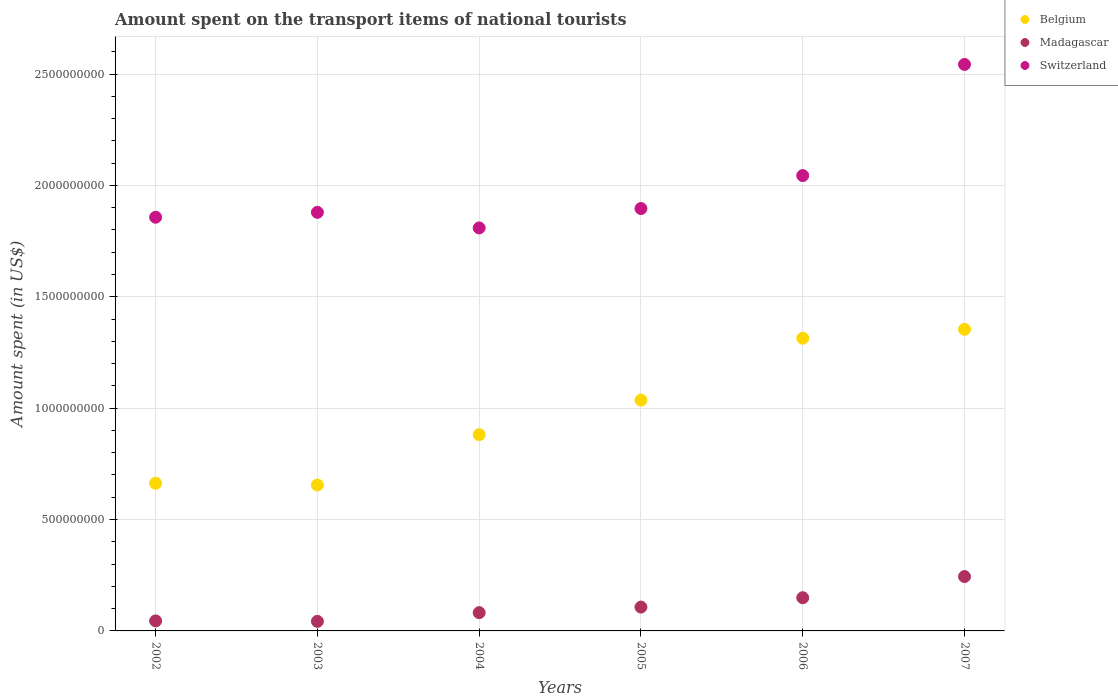How many different coloured dotlines are there?
Ensure brevity in your answer.  3. What is the amount spent on the transport items of national tourists in Madagascar in 2006?
Your answer should be compact. 1.49e+08. Across all years, what is the maximum amount spent on the transport items of national tourists in Switzerland?
Ensure brevity in your answer.  2.54e+09. Across all years, what is the minimum amount spent on the transport items of national tourists in Madagascar?
Your answer should be compact. 4.30e+07. What is the total amount spent on the transport items of national tourists in Madagascar in the graph?
Your response must be concise. 6.70e+08. What is the difference between the amount spent on the transport items of national tourists in Switzerland in 2002 and that in 2004?
Your response must be concise. 4.80e+07. What is the difference between the amount spent on the transport items of national tourists in Belgium in 2006 and the amount spent on the transport items of national tourists in Madagascar in 2002?
Your answer should be compact. 1.27e+09. What is the average amount spent on the transport items of national tourists in Madagascar per year?
Give a very brief answer. 1.12e+08. In the year 2002, what is the difference between the amount spent on the transport items of national tourists in Madagascar and amount spent on the transport items of national tourists in Switzerland?
Your response must be concise. -1.81e+09. In how many years, is the amount spent on the transport items of national tourists in Madagascar greater than 2100000000 US$?
Offer a terse response. 0. What is the ratio of the amount spent on the transport items of national tourists in Belgium in 2002 to that in 2006?
Your answer should be very brief. 0.5. Is the amount spent on the transport items of national tourists in Madagascar in 2006 less than that in 2007?
Your answer should be compact. Yes. Is the difference between the amount spent on the transport items of national tourists in Madagascar in 2002 and 2006 greater than the difference between the amount spent on the transport items of national tourists in Switzerland in 2002 and 2006?
Keep it short and to the point. Yes. What is the difference between the highest and the second highest amount spent on the transport items of national tourists in Madagascar?
Provide a succinct answer. 9.50e+07. What is the difference between the highest and the lowest amount spent on the transport items of national tourists in Switzerland?
Your answer should be very brief. 7.34e+08. Is the sum of the amount spent on the transport items of national tourists in Madagascar in 2004 and 2005 greater than the maximum amount spent on the transport items of national tourists in Belgium across all years?
Keep it short and to the point. No. Is the amount spent on the transport items of national tourists in Switzerland strictly less than the amount spent on the transport items of national tourists in Madagascar over the years?
Provide a short and direct response. No. How many dotlines are there?
Provide a short and direct response. 3. How many years are there in the graph?
Give a very brief answer. 6. Are the values on the major ticks of Y-axis written in scientific E-notation?
Provide a succinct answer. No. Does the graph contain grids?
Your answer should be compact. Yes. Where does the legend appear in the graph?
Keep it short and to the point. Top right. How many legend labels are there?
Your response must be concise. 3. What is the title of the graph?
Provide a succinct answer. Amount spent on the transport items of national tourists. What is the label or title of the Y-axis?
Offer a terse response. Amount spent (in US$). What is the Amount spent (in US$) of Belgium in 2002?
Your response must be concise. 6.63e+08. What is the Amount spent (in US$) in Madagascar in 2002?
Your answer should be very brief. 4.50e+07. What is the Amount spent (in US$) in Switzerland in 2002?
Your response must be concise. 1.86e+09. What is the Amount spent (in US$) of Belgium in 2003?
Provide a succinct answer. 6.55e+08. What is the Amount spent (in US$) of Madagascar in 2003?
Keep it short and to the point. 4.30e+07. What is the Amount spent (in US$) of Switzerland in 2003?
Offer a terse response. 1.88e+09. What is the Amount spent (in US$) of Belgium in 2004?
Ensure brevity in your answer.  8.81e+08. What is the Amount spent (in US$) of Madagascar in 2004?
Provide a succinct answer. 8.20e+07. What is the Amount spent (in US$) in Switzerland in 2004?
Provide a succinct answer. 1.81e+09. What is the Amount spent (in US$) of Belgium in 2005?
Your answer should be compact. 1.04e+09. What is the Amount spent (in US$) in Madagascar in 2005?
Offer a very short reply. 1.07e+08. What is the Amount spent (in US$) in Switzerland in 2005?
Provide a succinct answer. 1.90e+09. What is the Amount spent (in US$) in Belgium in 2006?
Offer a very short reply. 1.31e+09. What is the Amount spent (in US$) of Madagascar in 2006?
Your answer should be very brief. 1.49e+08. What is the Amount spent (in US$) in Switzerland in 2006?
Your response must be concise. 2.04e+09. What is the Amount spent (in US$) of Belgium in 2007?
Offer a terse response. 1.35e+09. What is the Amount spent (in US$) in Madagascar in 2007?
Your answer should be compact. 2.44e+08. What is the Amount spent (in US$) in Switzerland in 2007?
Your answer should be compact. 2.54e+09. Across all years, what is the maximum Amount spent (in US$) in Belgium?
Your answer should be compact. 1.35e+09. Across all years, what is the maximum Amount spent (in US$) in Madagascar?
Provide a short and direct response. 2.44e+08. Across all years, what is the maximum Amount spent (in US$) in Switzerland?
Offer a very short reply. 2.54e+09. Across all years, what is the minimum Amount spent (in US$) in Belgium?
Your answer should be very brief. 6.55e+08. Across all years, what is the minimum Amount spent (in US$) of Madagascar?
Ensure brevity in your answer.  4.30e+07. Across all years, what is the minimum Amount spent (in US$) in Switzerland?
Make the answer very short. 1.81e+09. What is the total Amount spent (in US$) of Belgium in the graph?
Keep it short and to the point. 5.90e+09. What is the total Amount spent (in US$) in Madagascar in the graph?
Your answer should be very brief. 6.70e+08. What is the total Amount spent (in US$) in Switzerland in the graph?
Ensure brevity in your answer.  1.20e+1. What is the difference between the Amount spent (in US$) in Madagascar in 2002 and that in 2003?
Provide a succinct answer. 2.00e+06. What is the difference between the Amount spent (in US$) of Switzerland in 2002 and that in 2003?
Your response must be concise. -2.20e+07. What is the difference between the Amount spent (in US$) in Belgium in 2002 and that in 2004?
Your response must be concise. -2.18e+08. What is the difference between the Amount spent (in US$) in Madagascar in 2002 and that in 2004?
Provide a succinct answer. -3.70e+07. What is the difference between the Amount spent (in US$) of Switzerland in 2002 and that in 2004?
Give a very brief answer. 4.80e+07. What is the difference between the Amount spent (in US$) of Belgium in 2002 and that in 2005?
Offer a very short reply. -3.73e+08. What is the difference between the Amount spent (in US$) of Madagascar in 2002 and that in 2005?
Ensure brevity in your answer.  -6.20e+07. What is the difference between the Amount spent (in US$) in Switzerland in 2002 and that in 2005?
Offer a terse response. -3.90e+07. What is the difference between the Amount spent (in US$) of Belgium in 2002 and that in 2006?
Offer a terse response. -6.51e+08. What is the difference between the Amount spent (in US$) in Madagascar in 2002 and that in 2006?
Offer a very short reply. -1.04e+08. What is the difference between the Amount spent (in US$) of Switzerland in 2002 and that in 2006?
Your answer should be very brief. -1.87e+08. What is the difference between the Amount spent (in US$) of Belgium in 2002 and that in 2007?
Offer a terse response. -6.91e+08. What is the difference between the Amount spent (in US$) in Madagascar in 2002 and that in 2007?
Make the answer very short. -1.99e+08. What is the difference between the Amount spent (in US$) in Switzerland in 2002 and that in 2007?
Your response must be concise. -6.86e+08. What is the difference between the Amount spent (in US$) in Belgium in 2003 and that in 2004?
Give a very brief answer. -2.26e+08. What is the difference between the Amount spent (in US$) of Madagascar in 2003 and that in 2004?
Your answer should be very brief. -3.90e+07. What is the difference between the Amount spent (in US$) of Switzerland in 2003 and that in 2004?
Ensure brevity in your answer.  7.00e+07. What is the difference between the Amount spent (in US$) of Belgium in 2003 and that in 2005?
Offer a very short reply. -3.81e+08. What is the difference between the Amount spent (in US$) of Madagascar in 2003 and that in 2005?
Your response must be concise. -6.40e+07. What is the difference between the Amount spent (in US$) of Switzerland in 2003 and that in 2005?
Give a very brief answer. -1.70e+07. What is the difference between the Amount spent (in US$) in Belgium in 2003 and that in 2006?
Ensure brevity in your answer.  -6.59e+08. What is the difference between the Amount spent (in US$) of Madagascar in 2003 and that in 2006?
Ensure brevity in your answer.  -1.06e+08. What is the difference between the Amount spent (in US$) of Switzerland in 2003 and that in 2006?
Provide a succinct answer. -1.65e+08. What is the difference between the Amount spent (in US$) of Belgium in 2003 and that in 2007?
Keep it short and to the point. -6.99e+08. What is the difference between the Amount spent (in US$) of Madagascar in 2003 and that in 2007?
Provide a short and direct response. -2.01e+08. What is the difference between the Amount spent (in US$) of Switzerland in 2003 and that in 2007?
Ensure brevity in your answer.  -6.64e+08. What is the difference between the Amount spent (in US$) of Belgium in 2004 and that in 2005?
Provide a succinct answer. -1.55e+08. What is the difference between the Amount spent (in US$) of Madagascar in 2004 and that in 2005?
Make the answer very short. -2.50e+07. What is the difference between the Amount spent (in US$) of Switzerland in 2004 and that in 2005?
Your response must be concise. -8.70e+07. What is the difference between the Amount spent (in US$) in Belgium in 2004 and that in 2006?
Provide a short and direct response. -4.33e+08. What is the difference between the Amount spent (in US$) in Madagascar in 2004 and that in 2006?
Make the answer very short. -6.70e+07. What is the difference between the Amount spent (in US$) of Switzerland in 2004 and that in 2006?
Make the answer very short. -2.35e+08. What is the difference between the Amount spent (in US$) in Belgium in 2004 and that in 2007?
Your response must be concise. -4.73e+08. What is the difference between the Amount spent (in US$) in Madagascar in 2004 and that in 2007?
Your answer should be compact. -1.62e+08. What is the difference between the Amount spent (in US$) in Switzerland in 2004 and that in 2007?
Offer a terse response. -7.34e+08. What is the difference between the Amount spent (in US$) of Belgium in 2005 and that in 2006?
Ensure brevity in your answer.  -2.78e+08. What is the difference between the Amount spent (in US$) in Madagascar in 2005 and that in 2006?
Your response must be concise. -4.20e+07. What is the difference between the Amount spent (in US$) of Switzerland in 2005 and that in 2006?
Ensure brevity in your answer.  -1.48e+08. What is the difference between the Amount spent (in US$) of Belgium in 2005 and that in 2007?
Offer a terse response. -3.18e+08. What is the difference between the Amount spent (in US$) in Madagascar in 2005 and that in 2007?
Offer a terse response. -1.37e+08. What is the difference between the Amount spent (in US$) of Switzerland in 2005 and that in 2007?
Keep it short and to the point. -6.47e+08. What is the difference between the Amount spent (in US$) of Belgium in 2006 and that in 2007?
Provide a short and direct response. -4.00e+07. What is the difference between the Amount spent (in US$) of Madagascar in 2006 and that in 2007?
Give a very brief answer. -9.50e+07. What is the difference between the Amount spent (in US$) in Switzerland in 2006 and that in 2007?
Your answer should be compact. -4.99e+08. What is the difference between the Amount spent (in US$) of Belgium in 2002 and the Amount spent (in US$) of Madagascar in 2003?
Provide a succinct answer. 6.20e+08. What is the difference between the Amount spent (in US$) of Belgium in 2002 and the Amount spent (in US$) of Switzerland in 2003?
Your answer should be very brief. -1.22e+09. What is the difference between the Amount spent (in US$) of Madagascar in 2002 and the Amount spent (in US$) of Switzerland in 2003?
Give a very brief answer. -1.83e+09. What is the difference between the Amount spent (in US$) of Belgium in 2002 and the Amount spent (in US$) of Madagascar in 2004?
Your answer should be compact. 5.81e+08. What is the difference between the Amount spent (in US$) of Belgium in 2002 and the Amount spent (in US$) of Switzerland in 2004?
Offer a terse response. -1.15e+09. What is the difference between the Amount spent (in US$) in Madagascar in 2002 and the Amount spent (in US$) in Switzerland in 2004?
Offer a terse response. -1.76e+09. What is the difference between the Amount spent (in US$) in Belgium in 2002 and the Amount spent (in US$) in Madagascar in 2005?
Your response must be concise. 5.56e+08. What is the difference between the Amount spent (in US$) of Belgium in 2002 and the Amount spent (in US$) of Switzerland in 2005?
Give a very brief answer. -1.23e+09. What is the difference between the Amount spent (in US$) of Madagascar in 2002 and the Amount spent (in US$) of Switzerland in 2005?
Your response must be concise. -1.85e+09. What is the difference between the Amount spent (in US$) in Belgium in 2002 and the Amount spent (in US$) in Madagascar in 2006?
Your answer should be very brief. 5.14e+08. What is the difference between the Amount spent (in US$) of Belgium in 2002 and the Amount spent (in US$) of Switzerland in 2006?
Your answer should be compact. -1.38e+09. What is the difference between the Amount spent (in US$) in Madagascar in 2002 and the Amount spent (in US$) in Switzerland in 2006?
Give a very brief answer. -2.00e+09. What is the difference between the Amount spent (in US$) of Belgium in 2002 and the Amount spent (in US$) of Madagascar in 2007?
Offer a very short reply. 4.19e+08. What is the difference between the Amount spent (in US$) of Belgium in 2002 and the Amount spent (in US$) of Switzerland in 2007?
Ensure brevity in your answer.  -1.88e+09. What is the difference between the Amount spent (in US$) of Madagascar in 2002 and the Amount spent (in US$) of Switzerland in 2007?
Make the answer very short. -2.50e+09. What is the difference between the Amount spent (in US$) in Belgium in 2003 and the Amount spent (in US$) in Madagascar in 2004?
Offer a very short reply. 5.73e+08. What is the difference between the Amount spent (in US$) in Belgium in 2003 and the Amount spent (in US$) in Switzerland in 2004?
Your answer should be very brief. -1.15e+09. What is the difference between the Amount spent (in US$) in Madagascar in 2003 and the Amount spent (in US$) in Switzerland in 2004?
Provide a short and direct response. -1.77e+09. What is the difference between the Amount spent (in US$) in Belgium in 2003 and the Amount spent (in US$) in Madagascar in 2005?
Give a very brief answer. 5.48e+08. What is the difference between the Amount spent (in US$) in Belgium in 2003 and the Amount spent (in US$) in Switzerland in 2005?
Ensure brevity in your answer.  -1.24e+09. What is the difference between the Amount spent (in US$) of Madagascar in 2003 and the Amount spent (in US$) of Switzerland in 2005?
Your response must be concise. -1.85e+09. What is the difference between the Amount spent (in US$) of Belgium in 2003 and the Amount spent (in US$) of Madagascar in 2006?
Offer a very short reply. 5.06e+08. What is the difference between the Amount spent (in US$) in Belgium in 2003 and the Amount spent (in US$) in Switzerland in 2006?
Your answer should be very brief. -1.39e+09. What is the difference between the Amount spent (in US$) in Madagascar in 2003 and the Amount spent (in US$) in Switzerland in 2006?
Your response must be concise. -2.00e+09. What is the difference between the Amount spent (in US$) of Belgium in 2003 and the Amount spent (in US$) of Madagascar in 2007?
Offer a very short reply. 4.11e+08. What is the difference between the Amount spent (in US$) of Belgium in 2003 and the Amount spent (in US$) of Switzerland in 2007?
Offer a terse response. -1.89e+09. What is the difference between the Amount spent (in US$) of Madagascar in 2003 and the Amount spent (in US$) of Switzerland in 2007?
Offer a terse response. -2.50e+09. What is the difference between the Amount spent (in US$) of Belgium in 2004 and the Amount spent (in US$) of Madagascar in 2005?
Your response must be concise. 7.74e+08. What is the difference between the Amount spent (in US$) of Belgium in 2004 and the Amount spent (in US$) of Switzerland in 2005?
Provide a short and direct response. -1.02e+09. What is the difference between the Amount spent (in US$) in Madagascar in 2004 and the Amount spent (in US$) in Switzerland in 2005?
Ensure brevity in your answer.  -1.81e+09. What is the difference between the Amount spent (in US$) of Belgium in 2004 and the Amount spent (in US$) of Madagascar in 2006?
Provide a short and direct response. 7.32e+08. What is the difference between the Amount spent (in US$) of Belgium in 2004 and the Amount spent (in US$) of Switzerland in 2006?
Give a very brief answer. -1.16e+09. What is the difference between the Amount spent (in US$) in Madagascar in 2004 and the Amount spent (in US$) in Switzerland in 2006?
Give a very brief answer. -1.96e+09. What is the difference between the Amount spent (in US$) of Belgium in 2004 and the Amount spent (in US$) of Madagascar in 2007?
Provide a short and direct response. 6.37e+08. What is the difference between the Amount spent (in US$) in Belgium in 2004 and the Amount spent (in US$) in Switzerland in 2007?
Provide a succinct answer. -1.66e+09. What is the difference between the Amount spent (in US$) of Madagascar in 2004 and the Amount spent (in US$) of Switzerland in 2007?
Keep it short and to the point. -2.46e+09. What is the difference between the Amount spent (in US$) in Belgium in 2005 and the Amount spent (in US$) in Madagascar in 2006?
Provide a short and direct response. 8.87e+08. What is the difference between the Amount spent (in US$) of Belgium in 2005 and the Amount spent (in US$) of Switzerland in 2006?
Provide a short and direct response. -1.01e+09. What is the difference between the Amount spent (in US$) in Madagascar in 2005 and the Amount spent (in US$) in Switzerland in 2006?
Your answer should be compact. -1.94e+09. What is the difference between the Amount spent (in US$) in Belgium in 2005 and the Amount spent (in US$) in Madagascar in 2007?
Offer a very short reply. 7.92e+08. What is the difference between the Amount spent (in US$) in Belgium in 2005 and the Amount spent (in US$) in Switzerland in 2007?
Make the answer very short. -1.51e+09. What is the difference between the Amount spent (in US$) of Madagascar in 2005 and the Amount spent (in US$) of Switzerland in 2007?
Offer a very short reply. -2.44e+09. What is the difference between the Amount spent (in US$) of Belgium in 2006 and the Amount spent (in US$) of Madagascar in 2007?
Provide a succinct answer. 1.07e+09. What is the difference between the Amount spent (in US$) of Belgium in 2006 and the Amount spent (in US$) of Switzerland in 2007?
Make the answer very short. -1.23e+09. What is the difference between the Amount spent (in US$) of Madagascar in 2006 and the Amount spent (in US$) of Switzerland in 2007?
Keep it short and to the point. -2.39e+09. What is the average Amount spent (in US$) in Belgium per year?
Your response must be concise. 9.84e+08. What is the average Amount spent (in US$) in Madagascar per year?
Give a very brief answer. 1.12e+08. What is the average Amount spent (in US$) of Switzerland per year?
Your answer should be very brief. 2.00e+09. In the year 2002, what is the difference between the Amount spent (in US$) of Belgium and Amount spent (in US$) of Madagascar?
Provide a short and direct response. 6.18e+08. In the year 2002, what is the difference between the Amount spent (in US$) in Belgium and Amount spent (in US$) in Switzerland?
Your answer should be compact. -1.19e+09. In the year 2002, what is the difference between the Amount spent (in US$) in Madagascar and Amount spent (in US$) in Switzerland?
Your answer should be compact. -1.81e+09. In the year 2003, what is the difference between the Amount spent (in US$) in Belgium and Amount spent (in US$) in Madagascar?
Your answer should be very brief. 6.12e+08. In the year 2003, what is the difference between the Amount spent (in US$) in Belgium and Amount spent (in US$) in Switzerland?
Keep it short and to the point. -1.22e+09. In the year 2003, what is the difference between the Amount spent (in US$) of Madagascar and Amount spent (in US$) of Switzerland?
Offer a very short reply. -1.84e+09. In the year 2004, what is the difference between the Amount spent (in US$) in Belgium and Amount spent (in US$) in Madagascar?
Your response must be concise. 7.99e+08. In the year 2004, what is the difference between the Amount spent (in US$) in Belgium and Amount spent (in US$) in Switzerland?
Make the answer very short. -9.28e+08. In the year 2004, what is the difference between the Amount spent (in US$) of Madagascar and Amount spent (in US$) of Switzerland?
Make the answer very short. -1.73e+09. In the year 2005, what is the difference between the Amount spent (in US$) of Belgium and Amount spent (in US$) of Madagascar?
Keep it short and to the point. 9.29e+08. In the year 2005, what is the difference between the Amount spent (in US$) of Belgium and Amount spent (in US$) of Switzerland?
Your response must be concise. -8.60e+08. In the year 2005, what is the difference between the Amount spent (in US$) in Madagascar and Amount spent (in US$) in Switzerland?
Keep it short and to the point. -1.79e+09. In the year 2006, what is the difference between the Amount spent (in US$) of Belgium and Amount spent (in US$) of Madagascar?
Provide a short and direct response. 1.16e+09. In the year 2006, what is the difference between the Amount spent (in US$) in Belgium and Amount spent (in US$) in Switzerland?
Offer a terse response. -7.30e+08. In the year 2006, what is the difference between the Amount spent (in US$) in Madagascar and Amount spent (in US$) in Switzerland?
Offer a very short reply. -1.90e+09. In the year 2007, what is the difference between the Amount spent (in US$) of Belgium and Amount spent (in US$) of Madagascar?
Offer a terse response. 1.11e+09. In the year 2007, what is the difference between the Amount spent (in US$) of Belgium and Amount spent (in US$) of Switzerland?
Keep it short and to the point. -1.19e+09. In the year 2007, what is the difference between the Amount spent (in US$) of Madagascar and Amount spent (in US$) of Switzerland?
Your answer should be very brief. -2.30e+09. What is the ratio of the Amount spent (in US$) in Belgium in 2002 to that in 2003?
Your answer should be compact. 1.01. What is the ratio of the Amount spent (in US$) in Madagascar in 2002 to that in 2003?
Ensure brevity in your answer.  1.05. What is the ratio of the Amount spent (in US$) in Switzerland in 2002 to that in 2003?
Give a very brief answer. 0.99. What is the ratio of the Amount spent (in US$) in Belgium in 2002 to that in 2004?
Offer a very short reply. 0.75. What is the ratio of the Amount spent (in US$) in Madagascar in 2002 to that in 2004?
Your response must be concise. 0.55. What is the ratio of the Amount spent (in US$) in Switzerland in 2002 to that in 2004?
Your answer should be compact. 1.03. What is the ratio of the Amount spent (in US$) of Belgium in 2002 to that in 2005?
Offer a very short reply. 0.64. What is the ratio of the Amount spent (in US$) of Madagascar in 2002 to that in 2005?
Your answer should be compact. 0.42. What is the ratio of the Amount spent (in US$) of Switzerland in 2002 to that in 2005?
Give a very brief answer. 0.98. What is the ratio of the Amount spent (in US$) of Belgium in 2002 to that in 2006?
Your answer should be very brief. 0.5. What is the ratio of the Amount spent (in US$) in Madagascar in 2002 to that in 2006?
Make the answer very short. 0.3. What is the ratio of the Amount spent (in US$) of Switzerland in 2002 to that in 2006?
Provide a short and direct response. 0.91. What is the ratio of the Amount spent (in US$) of Belgium in 2002 to that in 2007?
Give a very brief answer. 0.49. What is the ratio of the Amount spent (in US$) in Madagascar in 2002 to that in 2007?
Give a very brief answer. 0.18. What is the ratio of the Amount spent (in US$) in Switzerland in 2002 to that in 2007?
Give a very brief answer. 0.73. What is the ratio of the Amount spent (in US$) of Belgium in 2003 to that in 2004?
Your answer should be compact. 0.74. What is the ratio of the Amount spent (in US$) of Madagascar in 2003 to that in 2004?
Ensure brevity in your answer.  0.52. What is the ratio of the Amount spent (in US$) of Switzerland in 2003 to that in 2004?
Offer a terse response. 1.04. What is the ratio of the Amount spent (in US$) of Belgium in 2003 to that in 2005?
Ensure brevity in your answer.  0.63. What is the ratio of the Amount spent (in US$) in Madagascar in 2003 to that in 2005?
Your answer should be compact. 0.4. What is the ratio of the Amount spent (in US$) of Switzerland in 2003 to that in 2005?
Your answer should be compact. 0.99. What is the ratio of the Amount spent (in US$) in Belgium in 2003 to that in 2006?
Keep it short and to the point. 0.5. What is the ratio of the Amount spent (in US$) in Madagascar in 2003 to that in 2006?
Provide a short and direct response. 0.29. What is the ratio of the Amount spent (in US$) of Switzerland in 2003 to that in 2006?
Provide a short and direct response. 0.92. What is the ratio of the Amount spent (in US$) of Belgium in 2003 to that in 2007?
Provide a succinct answer. 0.48. What is the ratio of the Amount spent (in US$) of Madagascar in 2003 to that in 2007?
Offer a very short reply. 0.18. What is the ratio of the Amount spent (in US$) of Switzerland in 2003 to that in 2007?
Keep it short and to the point. 0.74. What is the ratio of the Amount spent (in US$) in Belgium in 2004 to that in 2005?
Offer a terse response. 0.85. What is the ratio of the Amount spent (in US$) of Madagascar in 2004 to that in 2005?
Your answer should be very brief. 0.77. What is the ratio of the Amount spent (in US$) in Switzerland in 2004 to that in 2005?
Offer a very short reply. 0.95. What is the ratio of the Amount spent (in US$) of Belgium in 2004 to that in 2006?
Your answer should be compact. 0.67. What is the ratio of the Amount spent (in US$) of Madagascar in 2004 to that in 2006?
Keep it short and to the point. 0.55. What is the ratio of the Amount spent (in US$) of Switzerland in 2004 to that in 2006?
Give a very brief answer. 0.89. What is the ratio of the Amount spent (in US$) in Belgium in 2004 to that in 2007?
Make the answer very short. 0.65. What is the ratio of the Amount spent (in US$) in Madagascar in 2004 to that in 2007?
Provide a short and direct response. 0.34. What is the ratio of the Amount spent (in US$) in Switzerland in 2004 to that in 2007?
Your answer should be very brief. 0.71. What is the ratio of the Amount spent (in US$) in Belgium in 2005 to that in 2006?
Provide a short and direct response. 0.79. What is the ratio of the Amount spent (in US$) in Madagascar in 2005 to that in 2006?
Provide a succinct answer. 0.72. What is the ratio of the Amount spent (in US$) of Switzerland in 2005 to that in 2006?
Provide a succinct answer. 0.93. What is the ratio of the Amount spent (in US$) of Belgium in 2005 to that in 2007?
Your response must be concise. 0.77. What is the ratio of the Amount spent (in US$) of Madagascar in 2005 to that in 2007?
Provide a succinct answer. 0.44. What is the ratio of the Amount spent (in US$) in Switzerland in 2005 to that in 2007?
Offer a very short reply. 0.75. What is the ratio of the Amount spent (in US$) in Belgium in 2006 to that in 2007?
Give a very brief answer. 0.97. What is the ratio of the Amount spent (in US$) of Madagascar in 2006 to that in 2007?
Provide a succinct answer. 0.61. What is the ratio of the Amount spent (in US$) in Switzerland in 2006 to that in 2007?
Keep it short and to the point. 0.8. What is the difference between the highest and the second highest Amount spent (in US$) of Belgium?
Provide a short and direct response. 4.00e+07. What is the difference between the highest and the second highest Amount spent (in US$) in Madagascar?
Keep it short and to the point. 9.50e+07. What is the difference between the highest and the second highest Amount spent (in US$) in Switzerland?
Your answer should be very brief. 4.99e+08. What is the difference between the highest and the lowest Amount spent (in US$) in Belgium?
Your answer should be very brief. 6.99e+08. What is the difference between the highest and the lowest Amount spent (in US$) of Madagascar?
Make the answer very short. 2.01e+08. What is the difference between the highest and the lowest Amount spent (in US$) of Switzerland?
Provide a short and direct response. 7.34e+08. 